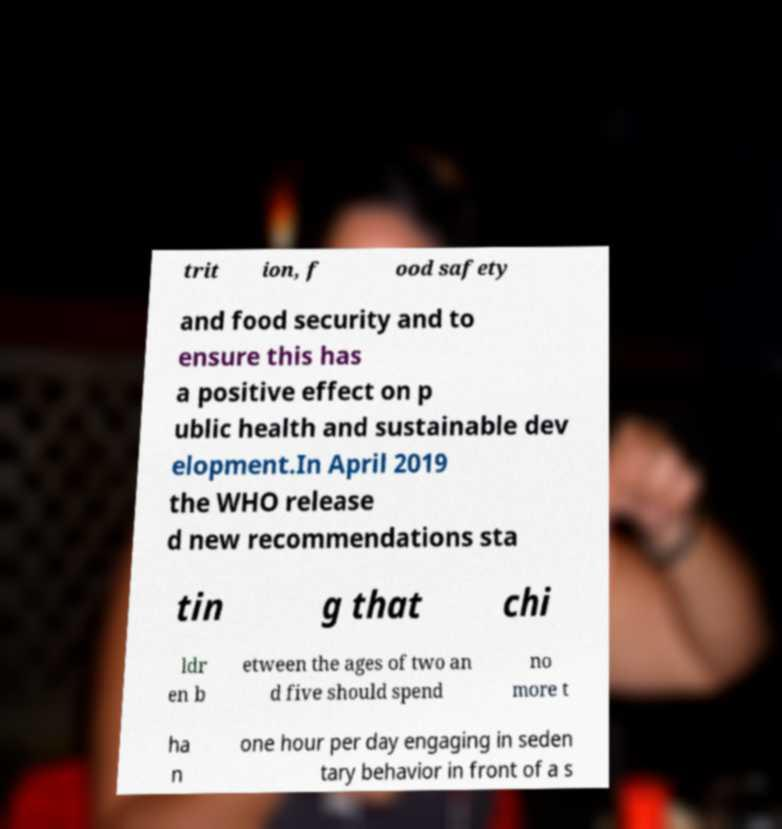Could you extract and type out the text from this image? trit ion, f ood safety and food security and to ensure this has a positive effect on p ublic health and sustainable dev elopment.In April 2019 the WHO release d new recommendations sta tin g that chi ldr en b etween the ages of two an d five should spend no more t ha n one hour per day engaging in seden tary behavior in front of a s 